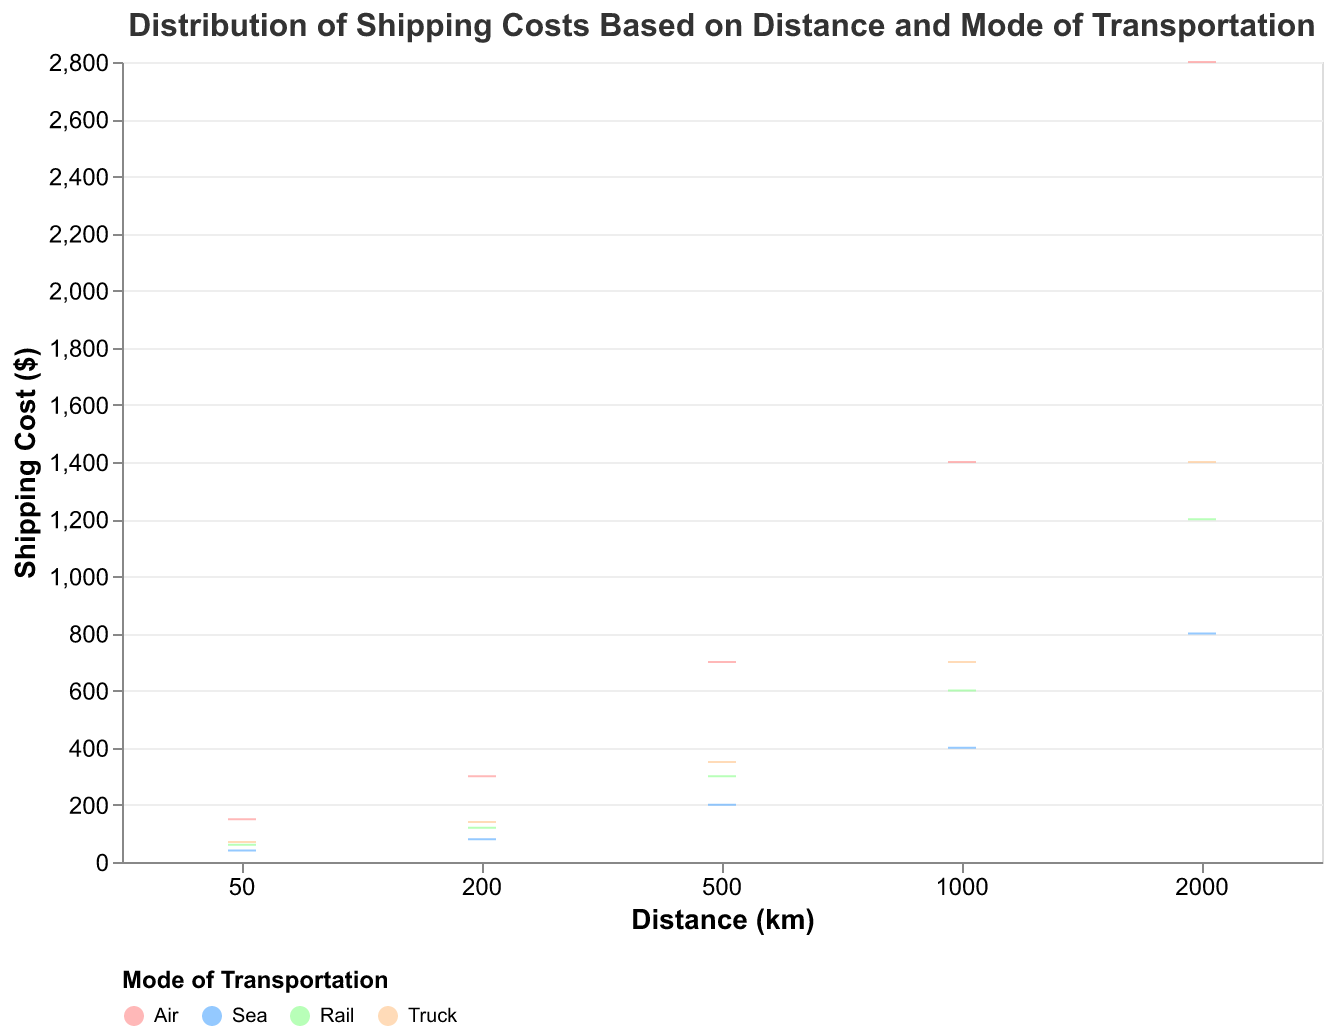What is the title of the figure? The title is located at the top of the figure, above the plot.
Answer: Distribution of Shipping Costs Based on Distance and Mode of Transportation How does the shipping cost for Air transportation compare to Sea transportation at a distance of 500 km? At 500 km, locate the boxes for both Air and Sea in the category of 'Distance (km)' = 500. Compare the positions of the boxes on the y-axis (Shipping Cost).
Answer: Air shipping costs significantly more than Sea shipping Which mode of transportation has the lowest shipping cost at 1000 km? Identify the category 'Distance (km)' = 1000, then look for the lowest box on the y-axis (Shipping Cost).
Answer: Sea What is the general trend observed for shipping costs as distance increases for Truck transportation? Observe the color representing Truck and its position across different distances on the x-axis. Note the behavior of the line as distance increases.
Answer: Shipping costs increase as distance increases for Truck transportation Among all modes of transportation, which has the highest shipping cost at 2000 km? Look at the 'Distance (km)' = 2000 and find the highest box or whisker on the y-axis. Check the corresponding color for the mode of transportation.
Answer: Air For a distance of 200 km, how much more expensive is Air transportation compared to Truck transportation? At 200 km, locate the boxes for both Air and Truck on the y-axis, and subtract the Truck cost from the Air cost.
Answer: $160 What is the range of shipping costs for Rail transportation at 1000 km? Identify the Rail color at 1000 km. The range is determined by the bottom and top of the whisker symbols extending from the box.
Answer: $600 How do the shipping costs for Sea and Rail transportation compare at 2000 km? At 2000 km, locate the boxes for both Sea and Rail. Compare their positions on the y-axis.
Answer: Rail is more expensive than Sea What is the mode of transportation with the highest variability in shipping costs across all distances? Determine which transportation mode has the largest spread in its boxes and whiskers on the y-axis when looking across all distances on the x-axis.
Answer: Air 